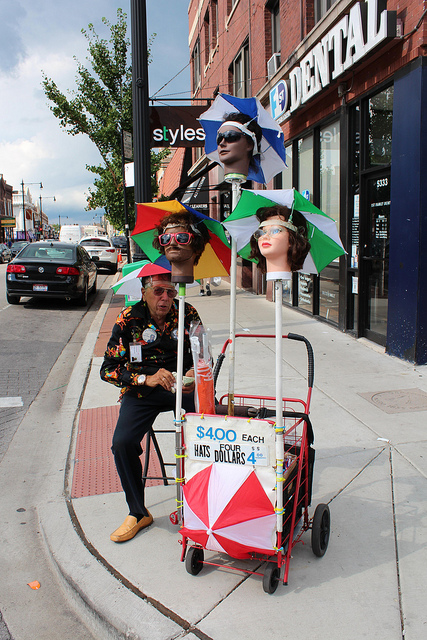Read and extract the text from this image. styles DENTAL 4.00 DOLLARS HATS 4 FOUR EACH 